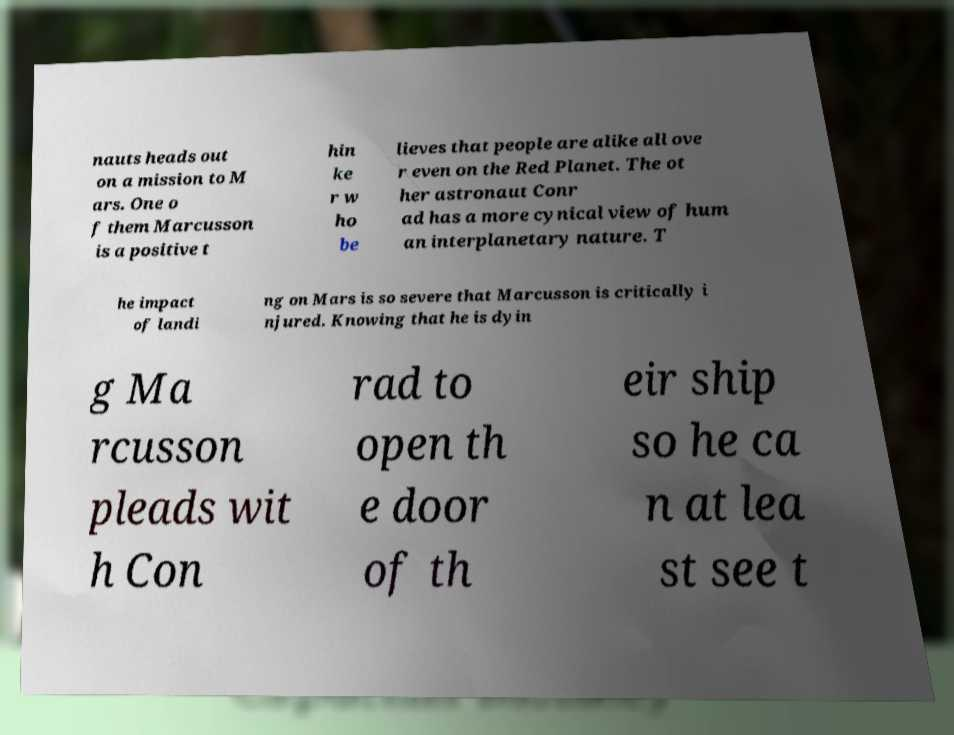Can you read and provide the text displayed in the image?This photo seems to have some interesting text. Can you extract and type it out for me? nauts heads out on a mission to M ars. One o f them Marcusson is a positive t hin ke r w ho be lieves that people are alike all ove r even on the Red Planet. The ot her astronaut Conr ad has a more cynical view of hum an interplanetary nature. T he impact of landi ng on Mars is so severe that Marcusson is critically i njured. Knowing that he is dyin g Ma rcusson pleads wit h Con rad to open th e door of th eir ship so he ca n at lea st see t 